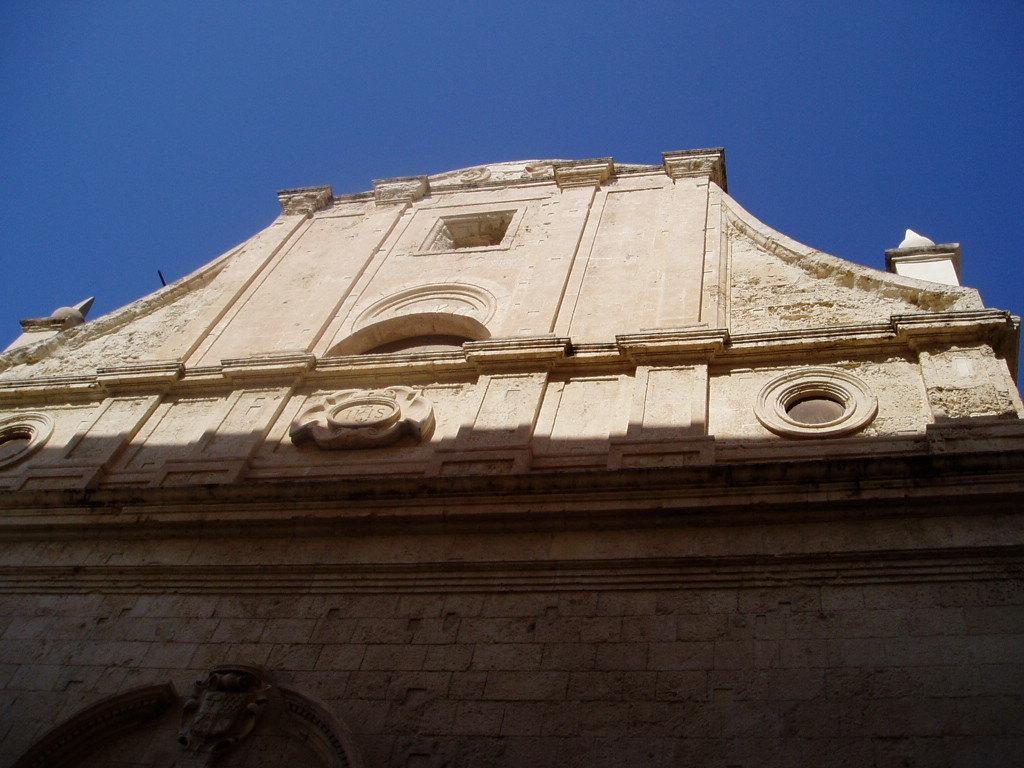What type of structure is present in the image? There is a building in the image. What can be seen at the top of the image? The sky is visible at the top of the image. What type of curve can be seen in the building's design in the image? There is no curve visible in the building's design in the image. What color are the veins in the sky in the image? There are no veins present in the sky in the image, as veins are not a characteristic of the sky. 